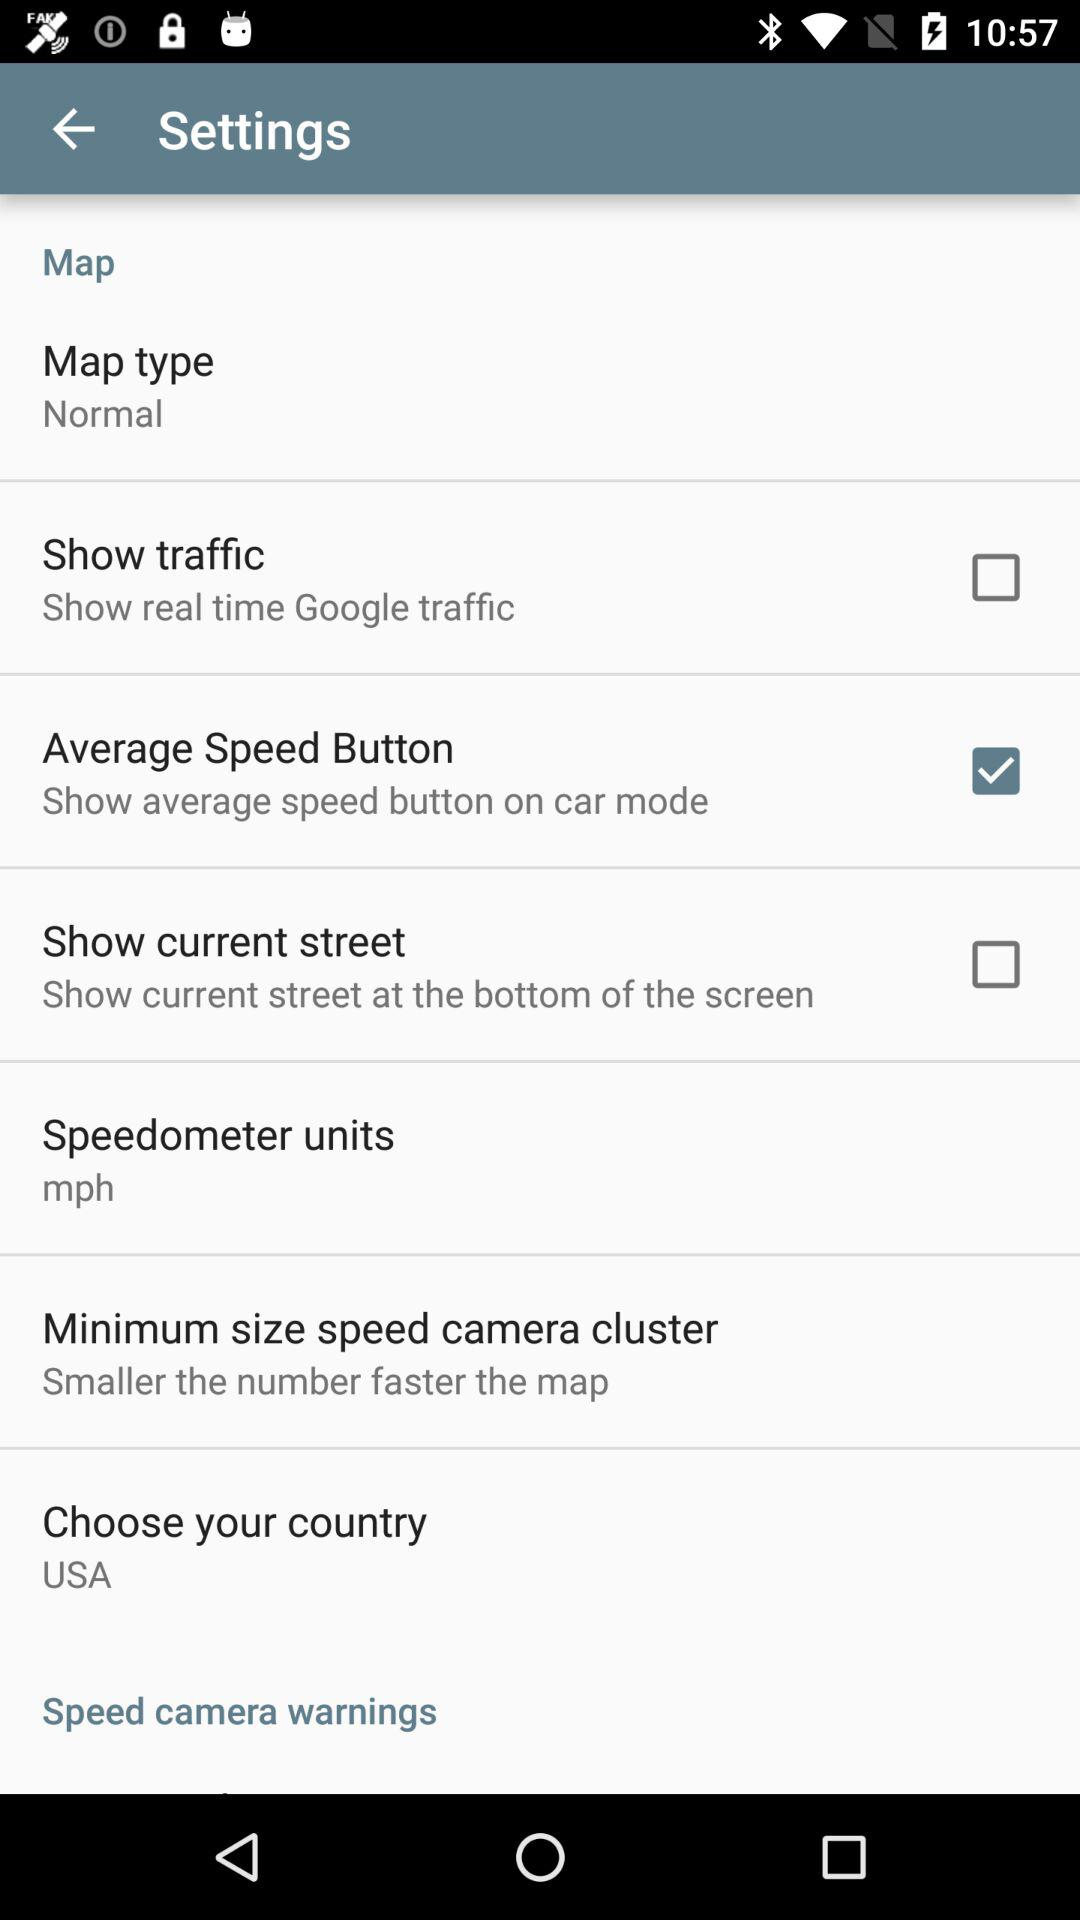What's the status of Show traffic? The status is off. 